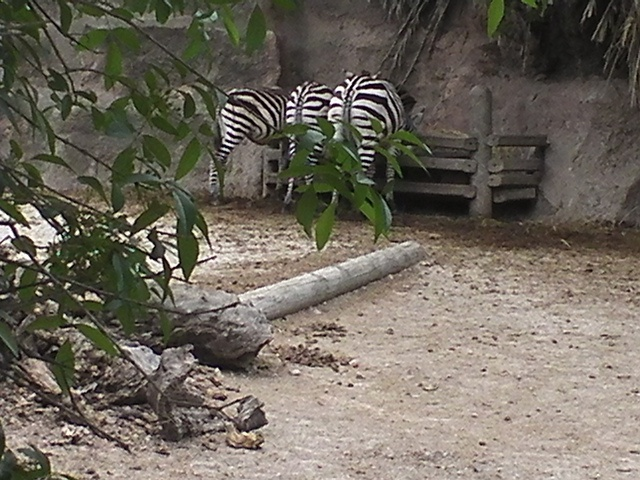Describe the objects in this image and their specific colors. I can see zebra in darkgreen, black, gray, darkgray, and lightgray tones, zebra in darkgreen, black, gray, and darkgray tones, and zebra in darkgreen, black, gray, darkgray, and lightgray tones in this image. 